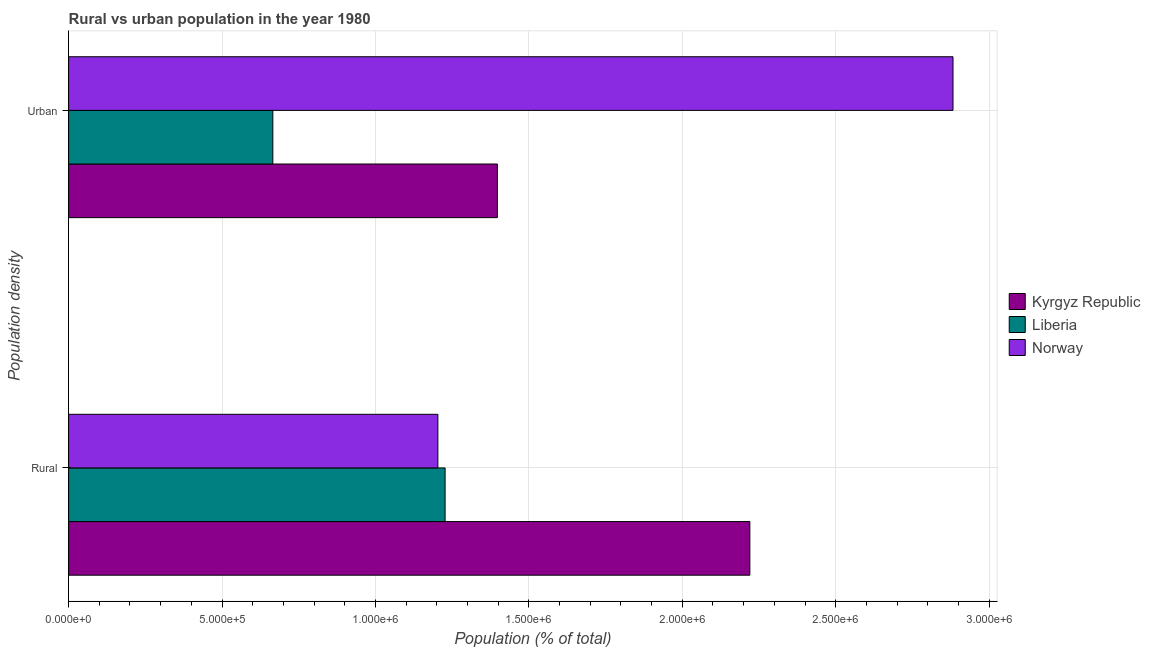How many groups of bars are there?
Give a very brief answer. 2. Are the number of bars per tick equal to the number of legend labels?
Your response must be concise. Yes. How many bars are there on the 2nd tick from the top?
Keep it short and to the point. 3. What is the label of the 1st group of bars from the top?
Offer a terse response. Urban. What is the urban population density in Norway?
Keep it short and to the point. 2.88e+06. Across all countries, what is the maximum urban population density?
Your response must be concise. 2.88e+06. Across all countries, what is the minimum urban population density?
Offer a terse response. 6.66e+05. In which country was the rural population density maximum?
Your answer should be compact. Kyrgyz Republic. In which country was the urban population density minimum?
Your response must be concise. Liberia. What is the total urban population density in the graph?
Your response must be concise. 4.95e+06. What is the difference between the rural population density in Kyrgyz Republic and that in Liberia?
Offer a terse response. 9.93e+05. What is the difference between the urban population density in Liberia and the rural population density in Norway?
Offer a terse response. -5.38e+05. What is the average urban population density per country?
Give a very brief answer. 1.65e+06. What is the difference between the rural population density and urban population density in Kyrgyz Republic?
Your answer should be compact. 8.23e+05. In how many countries, is the urban population density greater than 2900000 %?
Ensure brevity in your answer.  0. What is the ratio of the rural population density in Norway to that in Kyrgyz Republic?
Your response must be concise. 0.54. Is the urban population density in Kyrgyz Republic less than that in Norway?
Offer a terse response. Yes. What does the 2nd bar from the bottom in Urban represents?
Your answer should be compact. Liberia. Are all the bars in the graph horizontal?
Your response must be concise. Yes. Are the values on the major ticks of X-axis written in scientific E-notation?
Provide a short and direct response. Yes. How are the legend labels stacked?
Give a very brief answer. Vertical. What is the title of the graph?
Give a very brief answer. Rural vs urban population in the year 1980. What is the label or title of the X-axis?
Keep it short and to the point. Population (% of total). What is the label or title of the Y-axis?
Provide a short and direct response. Population density. What is the Population (% of total) of Kyrgyz Republic in Rural?
Make the answer very short. 2.22e+06. What is the Population (% of total) of Liberia in Rural?
Offer a very short reply. 1.23e+06. What is the Population (% of total) in Norway in Rural?
Provide a succinct answer. 1.20e+06. What is the Population (% of total) of Kyrgyz Republic in Urban?
Your answer should be compact. 1.40e+06. What is the Population (% of total) in Liberia in Urban?
Offer a terse response. 6.66e+05. What is the Population (% of total) of Norway in Urban?
Offer a very short reply. 2.88e+06. Across all Population density, what is the maximum Population (% of total) of Kyrgyz Republic?
Your response must be concise. 2.22e+06. Across all Population density, what is the maximum Population (% of total) of Liberia?
Your answer should be very brief. 1.23e+06. Across all Population density, what is the maximum Population (% of total) in Norway?
Your answer should be very brief. 2.88e+06. Across all Population density, what is the minimum Population (% of total) of Kyrgyz Republic?
Make the answer very short. 1.40e+06. Across all Population density, what is the minimum Population (% of total) in Liberia?
Your answer should be compact. 6.66e+05. Across all Population density, what is the minimum Population (% of total) in Norway?
Your response must be concise. 1.20e+06. What is the total Population (% of total) in Kyrgyz Republic in the graph?
Offer a very short reply. 3.62e+06. What is the total Population (% of total) of Liberia in the graph?
Your answer should be very brief. 1.89e+06. What is the total Population (% of total) of Norway in the graph?
Provide a succinct answer. 4.09e+06. What is the difference between the Population (% of total) in Kyrgyz Republic in Rural and that in Urban?
Ensure brevity in your answer.  8.23e+05. What is the difference between the Population (% of total) in Liberia in Rural and that in Urban?
Your answer should be very brief. 5.61e+05. What is the difference between the Population (% of total) in Norway in Rural and that in Urban?
Provide a succinct answer. -1.68e+06. What is the difference between the Population (% of total) in Kyrgyz Republic in Rural and the Population (% of total) in Liberia in Urban?
Your answer should be very brief. 1.55e+06. What is the difference between the Population (% of total) of Kyrgyz Republic in Rural and the Population (% of total) of Norway in Urban?
Offer a very short reply. -6.62e+05. What is the difference between the Population (% of total) in Liberia in Rural and the Population (% of total) in Norway in Urban?
Offer a terse response. -1.66e+06. What is the average Population (% of total) of Kyrgyz Republic per Population density?
Your answer should be compact. 1.81e+06. What is the average Population (% of total) of Liberia per Population density?
Your response must be concise. 9.46e+05. What is the average Population (% of total) of Norway per Population density?
Ensure brevity in your answer.  2.04e+06. What is the difference between the Population (% of total) of Kyrgyz Republic and Population (% of total) of Liberia in Rural?
Keep it short and to the point. 9.93e+05. What is the difference between the Population (% of total) in Kyrgyz Republic and Population (% of total) in Norway in Rural?
Keep it short and to the point. 1.02e+06. What is the difference between the Population (% of total) in Liberia and Population (% of total) in Norway in Rural?
Make the answer very short. 2.36e+04. What is the difference between the Population (% of total) of Kyrgyz Republic and Population (% of total) of Liberia in Urban?
Keep it short and to the point. 7.32e+05. What is the difference between the Population (% of total) of Kyrgyz Republic and Population (% of total) of Norway in Urban?
Offer a very short reply. -1.48e+06. What is the difference between the Population (% of total) of Liberia and Population (% of total) of Norway in Urban?
Ensure brevity in your answer.  -2.22e+06. What is the ratio of the Population (% of total) in Kyrgyz Republic in Rural to that in Urban?
Provide a succinct answer. 1.59. What is the ratio of the Population (% of total) in Liberia in Rural to that in Urban?
Make the answer very short. 1.84. What is the ratio of the Population (% of total) in Norway in Rural to that in Urban?
Offer a very short reply. 0.42. What is the difference between the highest and the second highest Population (% of total) of Kyrgyz Republic?
Offer a very short reply. 8.23e+05. What is the difference between the highest and the second highest Population (% of total) in Liberia?
Ensure brevity in your answer.  5.61e+05. What is the difference between the highest and the second highest Population (% of total) in Norway?
Give a very brief answer. 1.68e+06. What is the difference between the highest and the lowest Population (% of total) in Kyrgyz Republic?
Keep it short and to the point. 8.23e+05. What is the difference between the highest and the lowest Population (% of total) in Liberia?
Your answer should be very brief. 5.61e+05. What is the difference between the highest and the lowest Population (% of total) in Norway?
Make the answer very short. 1.68e+06. 